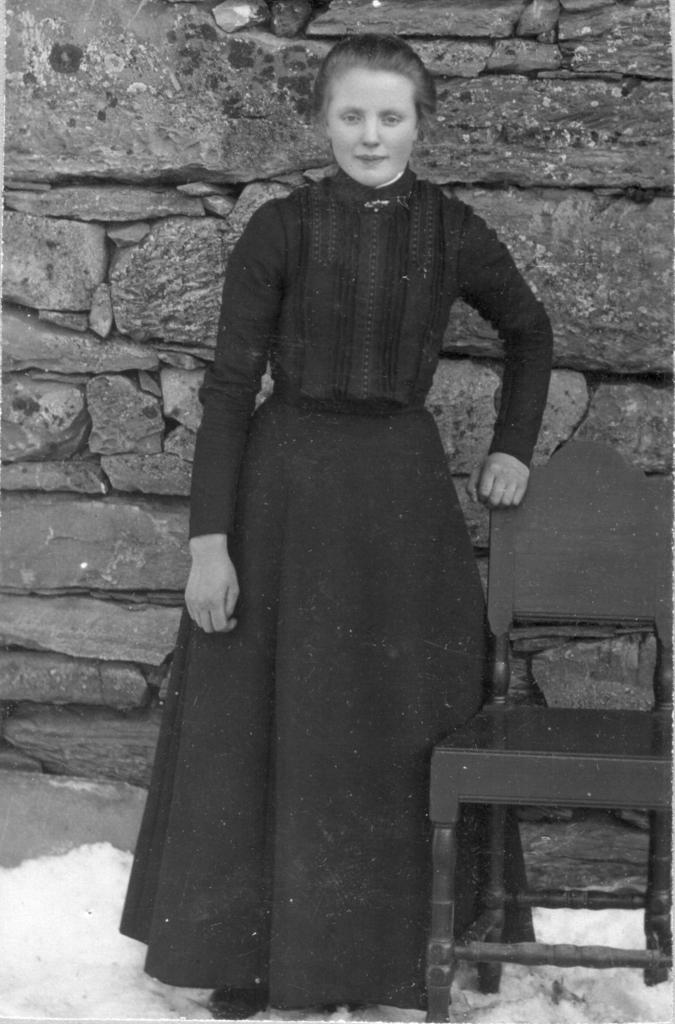What type of furniture is present in the image? There is a chair in the image. What is the background of the image? There is a wall in the image. Who is present in the image? There is a woman standing in the image. What is the color scheme of the image? The image is black and white in color. What type of crook can be seen in the image? There is no crook present in the image. What act is the woman performing in the image? The image does not depict any specific act being performed by the woman. 